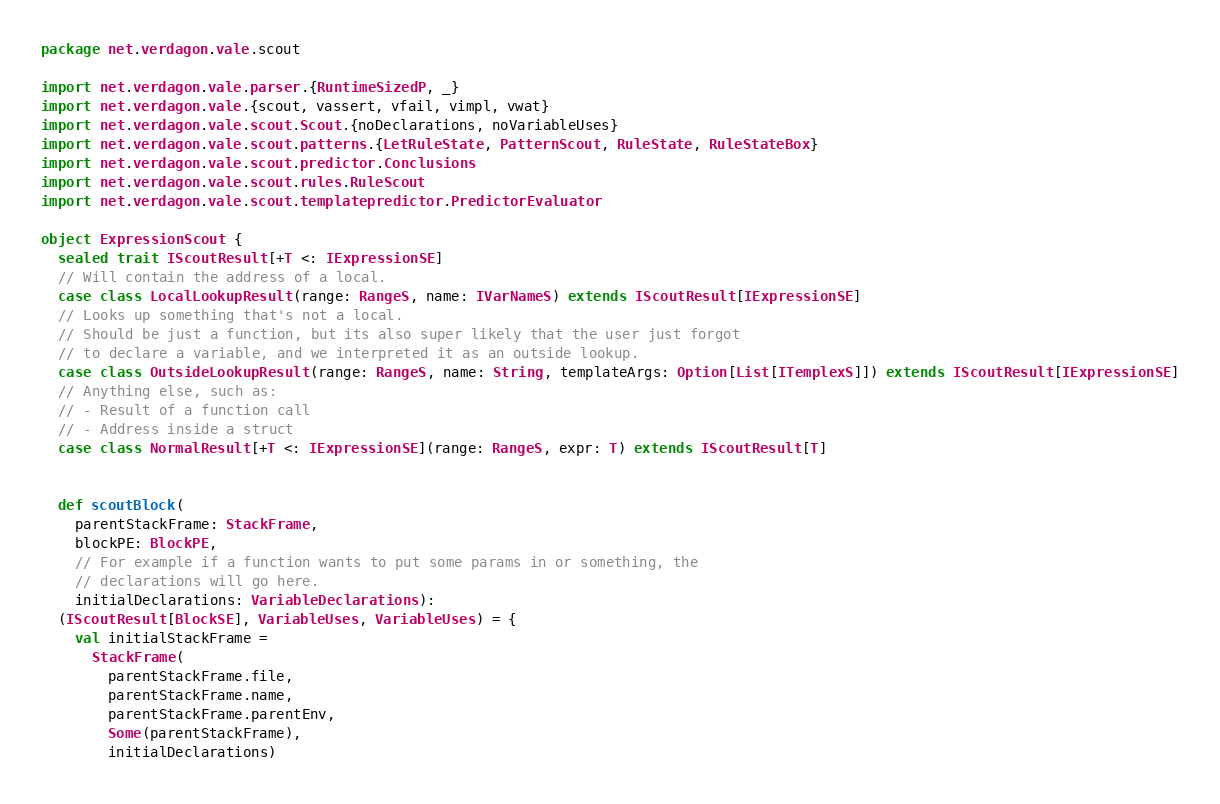<code> <loc_0><loc_0><loc_500><loc_500><_Scala_>package net.verdagon.vale.scout

import net.verdagon.vale.parser.{RuntimeSizedP, _}
import net.verdagon.vale.{scout, vassert, vfail, vimpl, vwat}
import net.verdagon.vale.scout.Scout.{noDeclarations, noVariableUses}
import net.verdagon.vale.scout.patterns.{LetRuleState, PatternScout, RuleState, RuleStateBox}
import net.verdagon.vale.scout.predictor.Conclusions
import net.verdagon.vale.scout.rules.RuleScout
import net.verdagon.vale.scout.templatepredictor.PredictorEvaluator

object ExpressionScout {
  sealed trait IScoutResult[+T <: IExpressionSE]
  // Will contain the address of a local.
  case class LocalLookupResult(range: RangeS, name: IVarNameS) extends IScoutResult[IExpressionSE]
  // Looks up something that's not a local.
  // Should be just a function, but its also super likely that the user just forgot
  // to declare a variable, and we interpreted it as an outside lookup.
  case class OutsideLookupResult(range: RangeS, name: String, templateArgs: Option[List[ITemplexS]]) extends IScoutResult[IExpressionSE]
  // Anything else, such as:
  // - Result of a function call
  // - Address inside a struct
  case class NormalResult[+T <: IExpressionSE](range: RangeS, expr: T) extends IScoutResult[T]


  def scoutBlock(
    parentStackFrame: StackFrame,
    blockPE: BlockPE,
    // For example if a function wants to put some params in or something, the
    // declarations will go here.
    initialDeclarations: VariableDeclarations):
  (IScoutResult[BlockSE], VariableUses, VariableUses) = {
    val initialStackFrame =
      StackFrame(
        parentStackFrame.file,
        parentStackFrame.name,
        parentStackFrame.parentEnv,
        Some(parentStackFrame),
        initialDeclarations)
</code> 